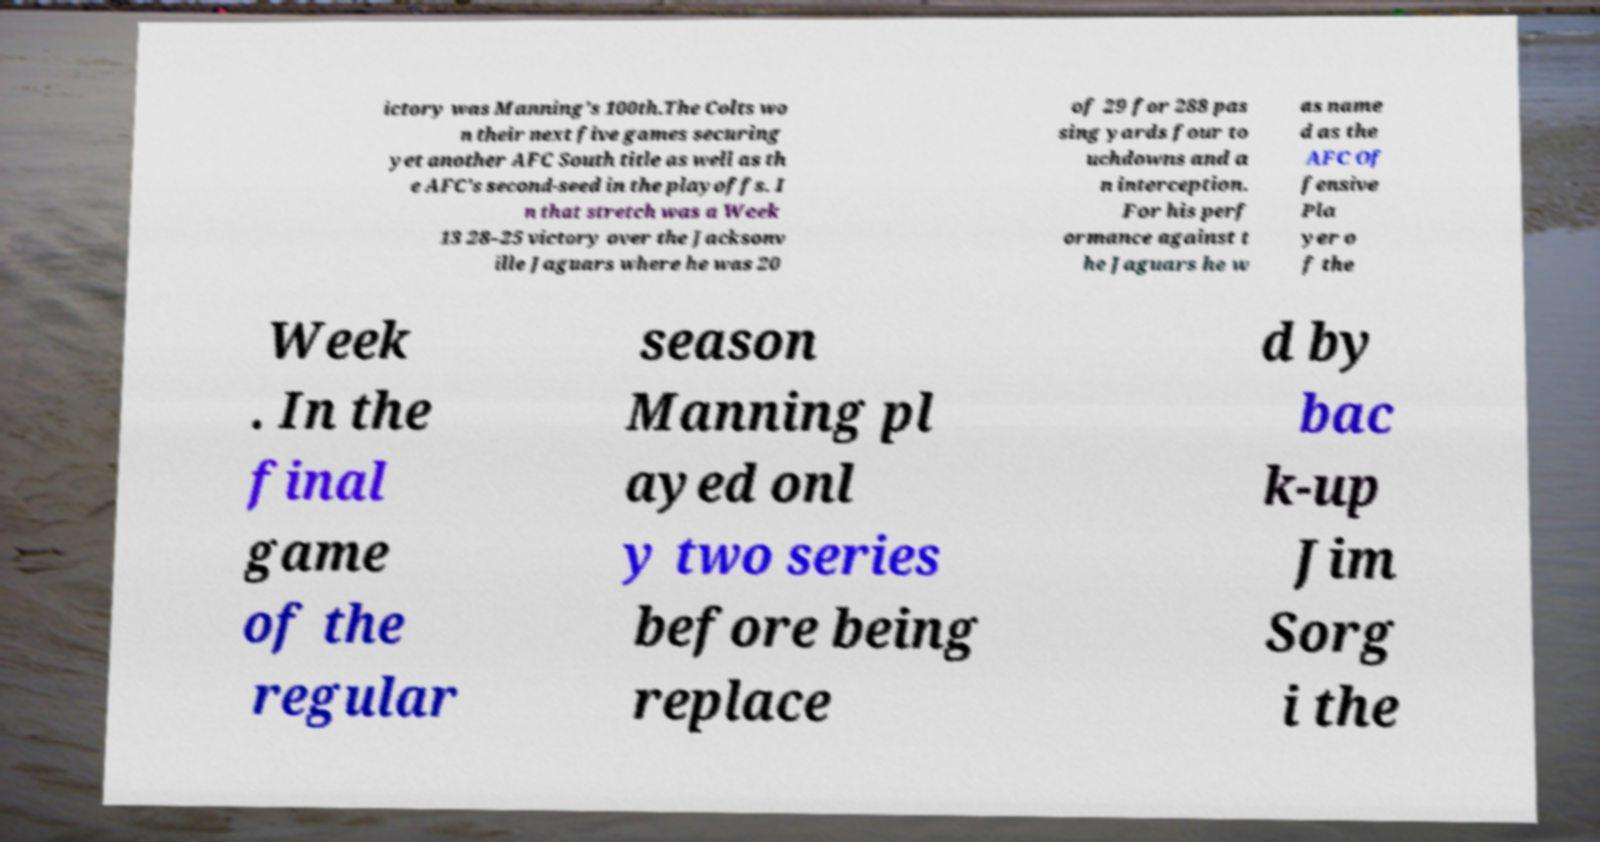I need the written content from this picture converted into text. Can you do that? ictory was Manning's 100th.The Colts wo n their next five games securing yet another AFC South title as well as th e AFC's second-seed in the playoffs. I n that stretch was a Week 13 28–25 victory over the Jacksonv ille Jaguars where he was 20 of 29 for 288 pas sing yards four to uchdowns and a n interception. For his perf ormance against t he Jaguars he w as name d as the AFC Of fensive Pla yer o f the Week . In the final game of the regular season Manning pl ayed onl y two series before being replace d by bac k-up Jim Sorg i the 